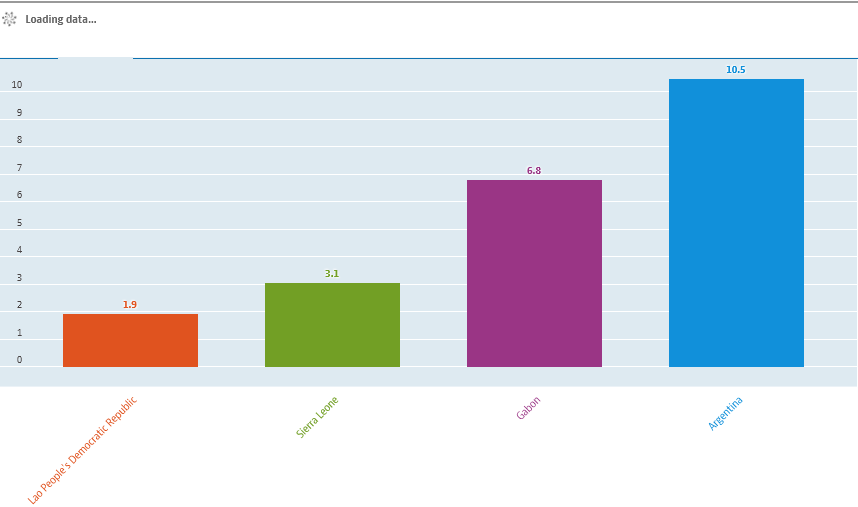List a handful of essential elements in this visual. Argentina is represented by the blue bar in the graph. The difference in the value of the smallest two bars is not greater than the difference in the value of the largest two bars. 